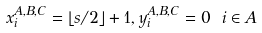<formula> <loc_0><loc_0><loc_500><loc_500>x ^ { A , B , C } _ { i } = \lfloor s / 2 \rfloor + 1 , y ^ { A , B , C } _ { i } = 0 \ i \in A</formula> 